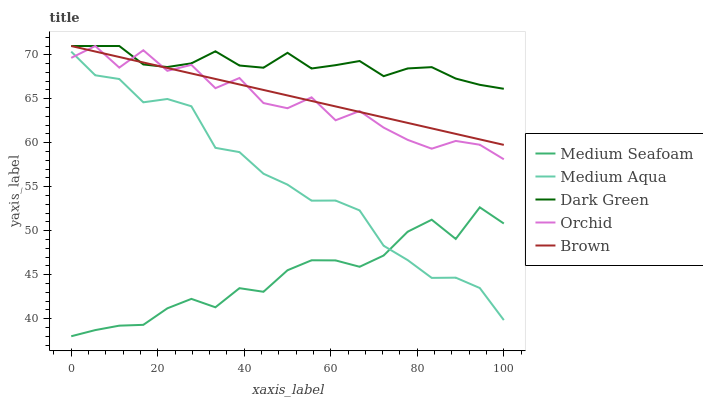Does Medium Seafoam have the minimum area under the curve?
Answer yes or no. Yes. Does Dark Green have the maximum area under the curve?
Answer yes or no. Yes. Does Orchid have the minimum area under the curve?
Answer yes or no. No. Does Orchid have the maximum area under the curve?
Answer yes or no. No. Is Brown the smoothest?
Answer yes or no. Yes. Is Orchid the roughest?
Answer yes or no. Yes. Is Medium Aqua the smoothest?
Answer yes or no. No. Is Medium Aqua the roughest?
Answer yes or no. No. Does Medium Seafoam have the lowest value?
Answer yes or no. Yes. Does Orchid have the lowest value?
Answer yes or no. No. Does Dark Green have the highest value?
Answer yes or no. Yes. Does Medium Aqua have the highest value?
Answer yes or no. No. Is Medium Aqua less than Dark Green?
Answer yes or no. Yes. Is Orchid greater than Medium Seafoam?
Answer yes or no. Yes. Does Medium Aqua intersect Medium Seafoam?
Answer yes or no. Yes. Is Medium Aqua less than Medium Seafoam?
Answer yes or no. No. Is Medium Aqua greater than Medium Seafoam?
Answer yes or no. No. Does Medium Aqua intersect Dark Green?
Answer yes or no. No. 